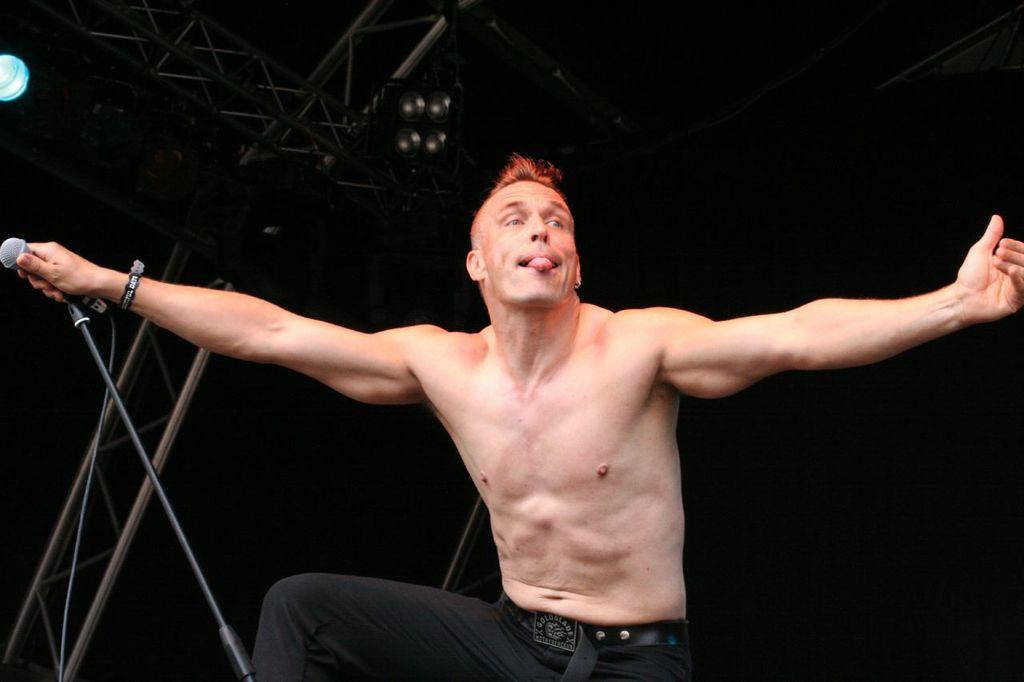Who is the main subject in the image? There is a person in the center of the image. What is the person doing in the image? The person is standing and holding a microphone. What can be seen in the background of the image? There are poles in the background of the image, and lights are at the top of the poles. What type of skirt is the person wearing in the image? The image does not show the person wearing a skirt, so it cannot be determined from the image. 